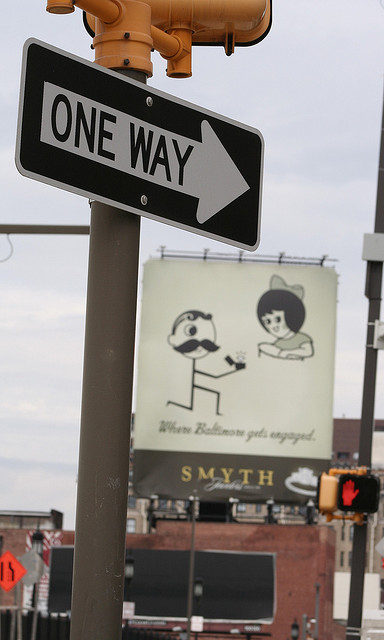<image>What is above the "No Left Turn" sign? I'm not sure what is above the "No Left Turn" sign. It could be a light, street light, one way sign, or traffic light. What is above the "No Left Turn" sign? It is ambiguous what is above the "No Left Turn" sign. It can be seen a light, a street light, a one way sign, or a traffic light. 